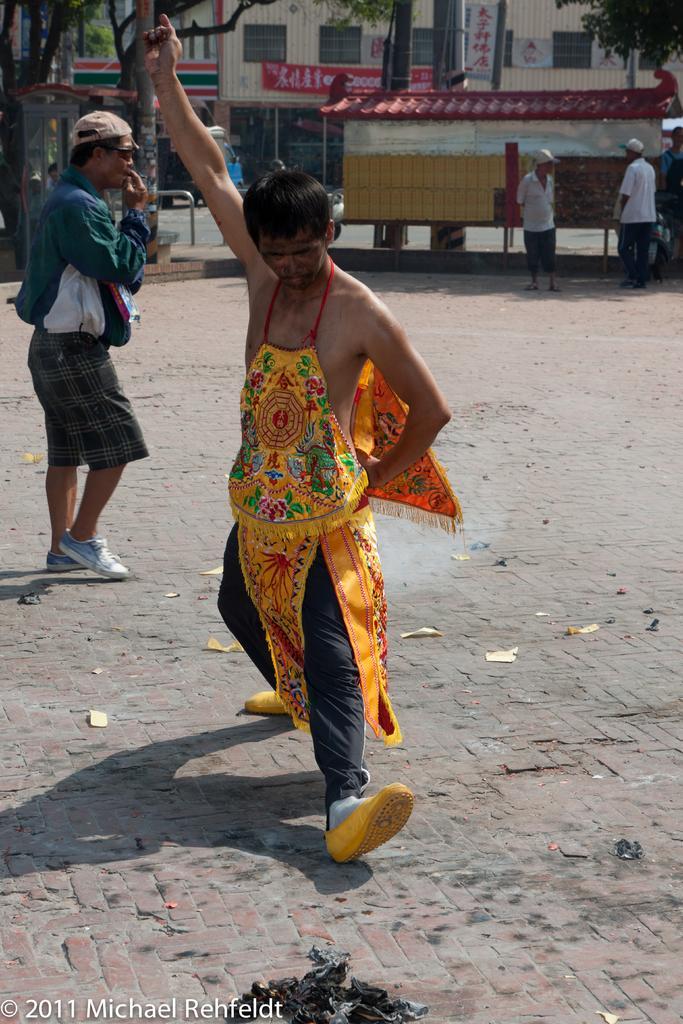Describe this image in one or two sentences. In this image we can see a man standing on the road. We can also see another man with cap on the left. In the background we can see the buildings, trees, road and also three persons. We can see some papers and the black color cover on the road. In the bottom left corner there is text. 